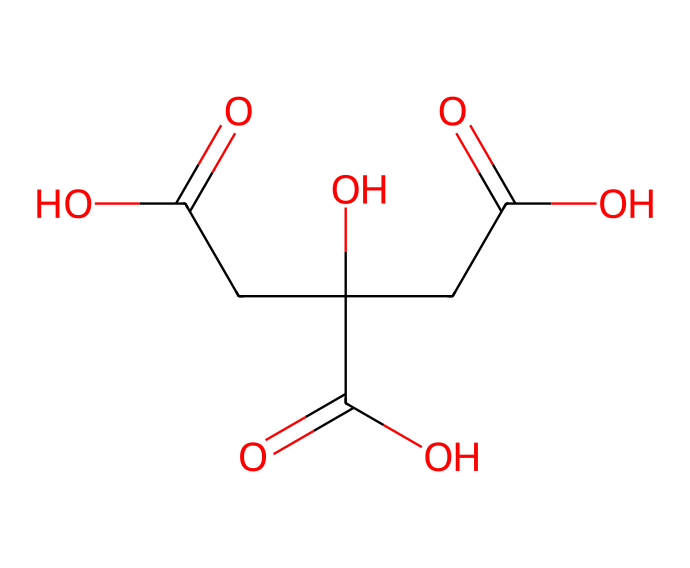What is the chemical name of the compound represented by this SMILES? The SMILES representation corresponds to a molecule that has three carboxylic acid functional groups, commonly known as citric acid.
Answer: citric acid How many carboxylic acid groups are present in this structure? The SMILES indicates the presence of three -COOH groups, confirming that there are three carboxylic acid groups in the structure.
Answer: three What is the total number of carbon atoms in this molecule? By analyzing the carbon atoms present in the SMILES, there are six carbon atoms that can be counted directly from the structure.
Answer: six Based on its structure, is this compound likely to be an acid or a base? The presence of multiple carboxylic acid groups suggests that citric acid contains acidic properties, classifying it primarily as an acid rather than a base.
Answer: acid How many hydrogen atoms are in the molecule? By calculating the number of hydrogen atoms associated with each carbon and considering the -COOH groups, this compound has eight hydrogen atoms in total.
Answer: eight What would be the effect of citric acid on pH in a solution? As a weak acid, citric acid would lower the pH of a solution when dissolved, indicating its effect as an acid in gaming drinks.
Answer: lowers pH Is citric acid a strong or weak acid? Citric acid is categorized as a weak acid due to its partial dissociation in solution, meaning it does not completely ionize.
Answer: weak acid 